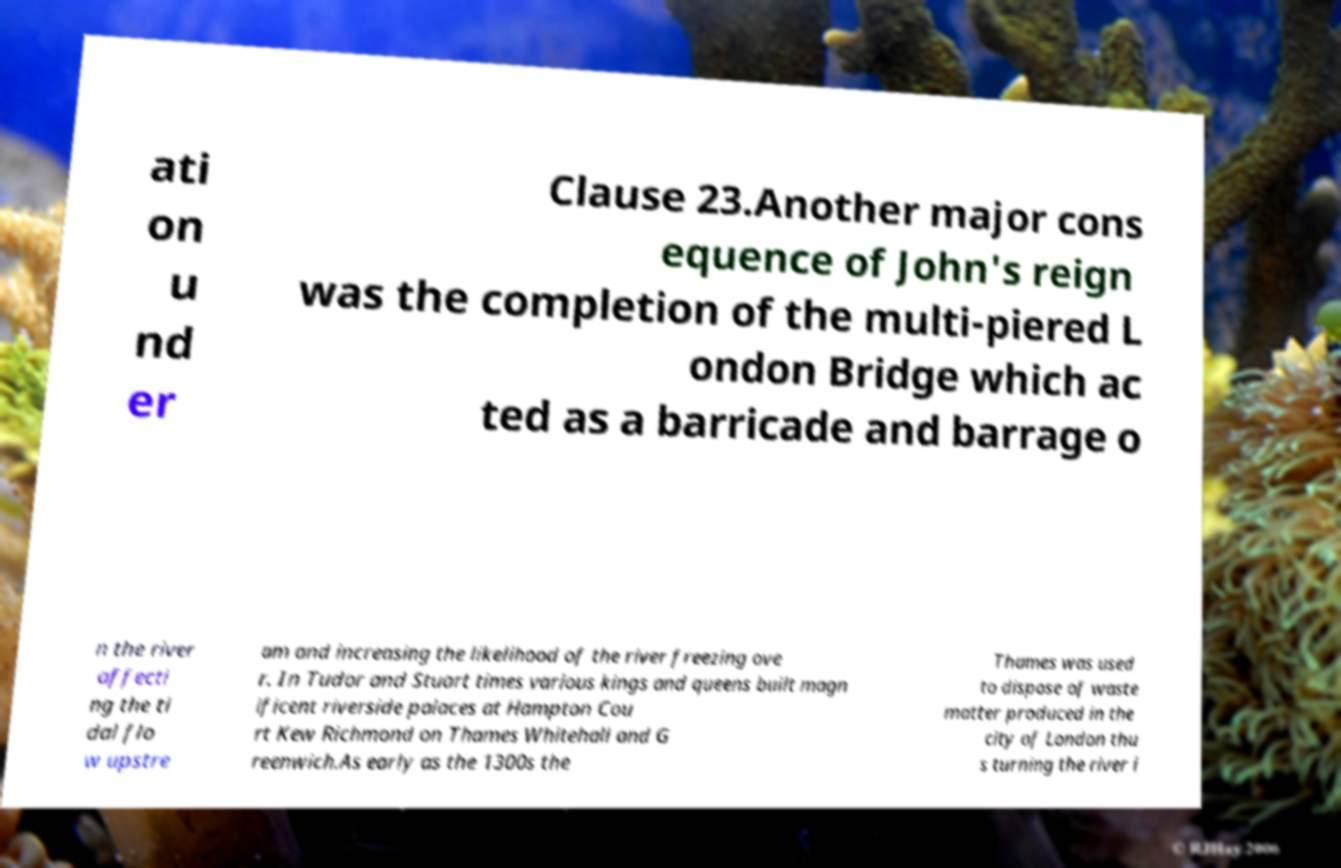For documentation purposes, I need the text within this image transcribed. Could you provide that? ati on u nd er Clause 23.Another major cons equence of John's reign was the completion of the multi-piered L ondon Bridge which ac ted as a barricade and barrage o n the river affecti ng the ti dal flo w upstre am and increasing the likelihood of the river freezing ove r. In Tudor and Stuart times various kings and queens built magn ificent riverside palaces at Hampton Cou rt Kew Richmond on Thames Whitehall and G reenwich.As early as the 1300s the Thames was used to dispose of waste matter produced in the city of London thu s turning the river i 